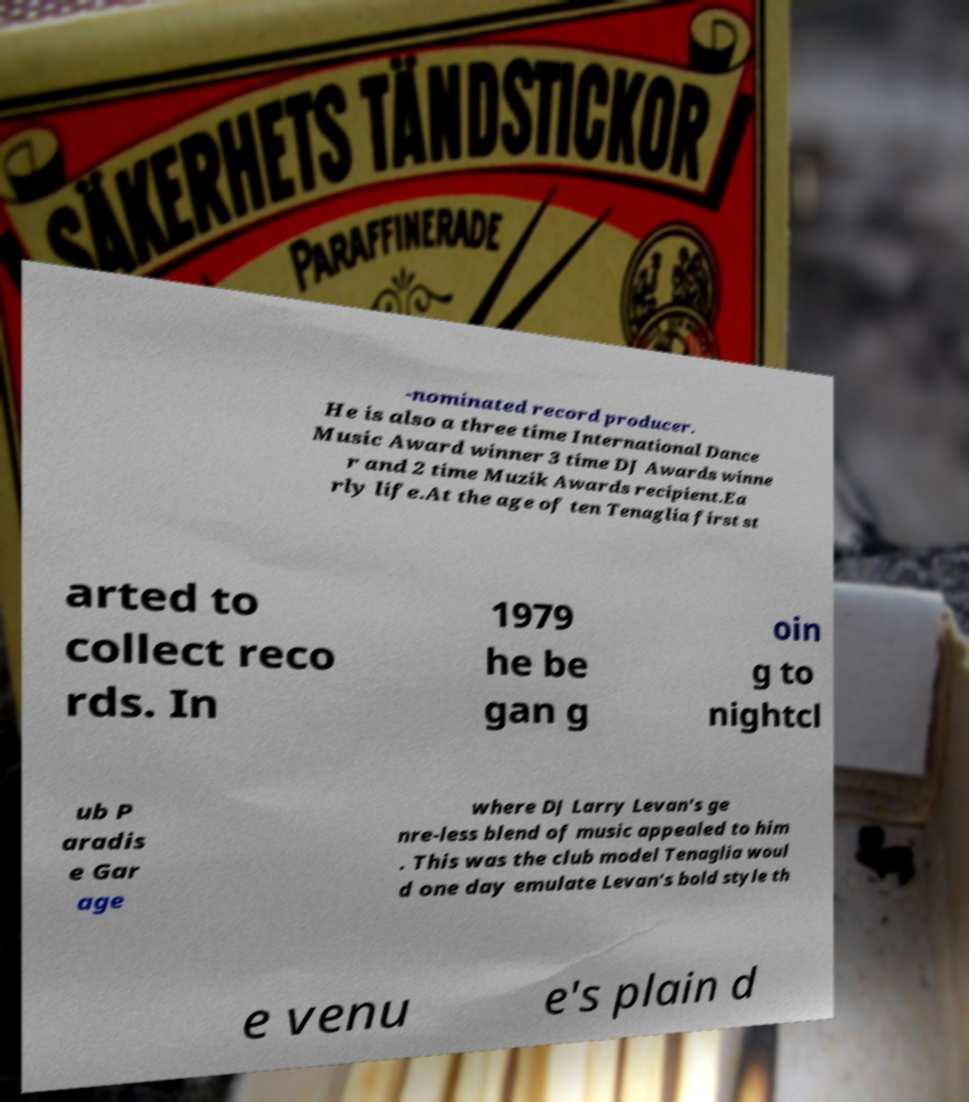Please read and relay the text visible in this image. What does it say? -nominated record producer. He is also a three time International Dance Music Award winner 3 time DJ Awards winne r and 2 time Muzik Awards recipient.Ea rly life.At the age of ten Tenaglia first st arted to collect reco rds. In 1979 he be gan g oin g to nightcl ub P aradis e Gar age where DJ Larry Levan's ge nre-less blend of music appealed to him . This was the club model Tenaglia woul d one day emulate Levan's bold style th e venu e's plain d 